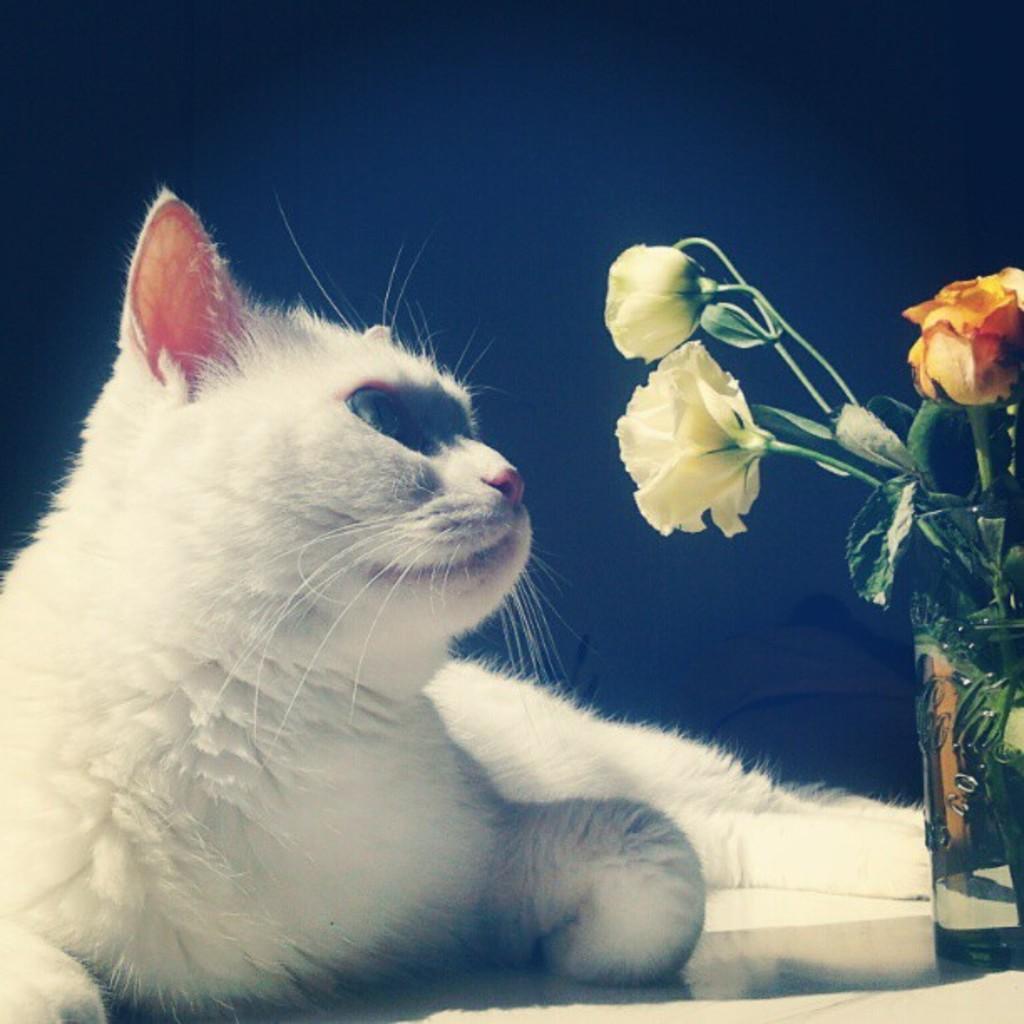Can you describe this image briefly? In this image there is a cat lying on the floor. In front of it there is a glass. In the glass there are rose flowers. 